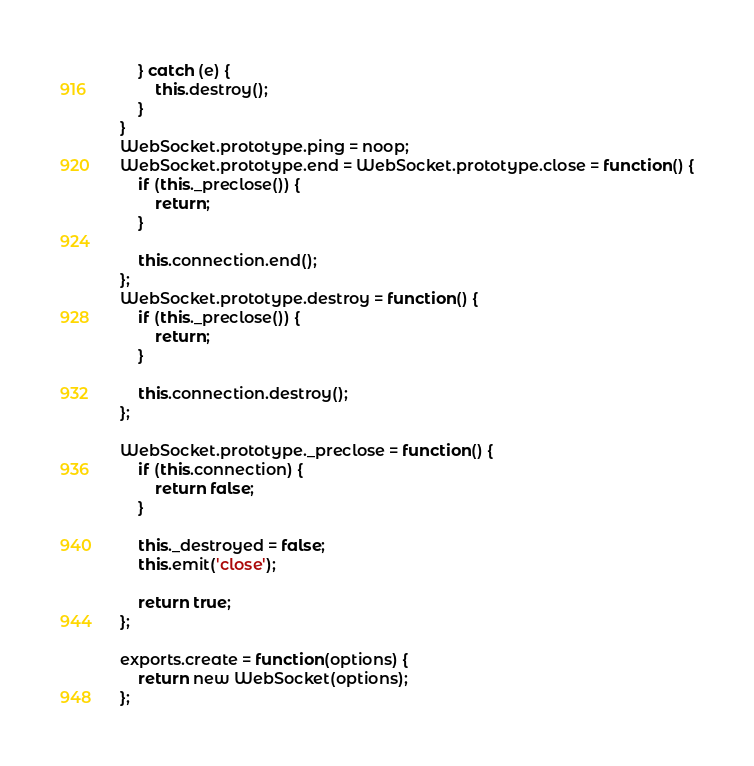Convert code to text. <code><loc_0><loc_0><loc_500><loc_500><_JavaScript_>	} catch (e) {
		this.destroy();
	}
}
WebSocket.prototype.ping = noop;
WebSocket.prototype.end = WebSocket.prototype.close = function() {
	if (this._preclose()) {
		return;	
	}

	this.connection.end();
};
WebSocket.prototype.destroy = function() {
	if (this._preclose()) {
		return;	
	}
	
	this.connection.destroy();
};

WebSocket.prototype._preclose = function() {
	if (this.connection) {
		return false;
	}

	this._destroyed = false;
	this.emit('close');	

	return true;	
};

exports.create = function(options) {
	return new WebSocket(options);
};</code> 